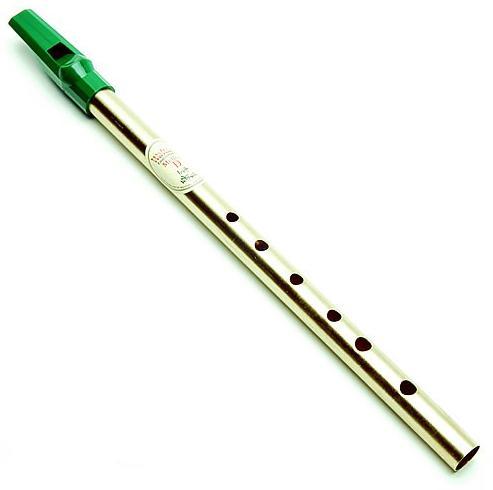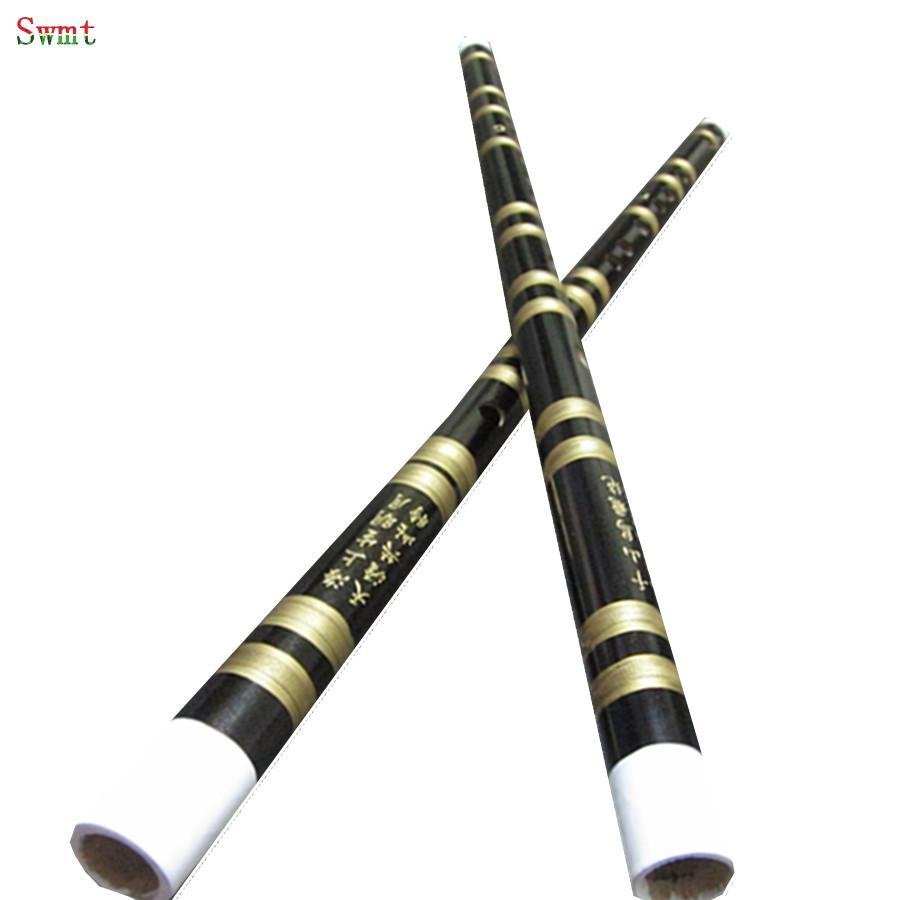The first image is the image on the left, the second image is the image on the right. Analyze the images presented: Is the assertion "There are exactly two flutes." valid? Answer yes or no. No. The first image is the image on the left, the second image is the image on the right. Given the left and right images, does the statement "There is a total of two instruments." hold true? Answer yes or no. No. 